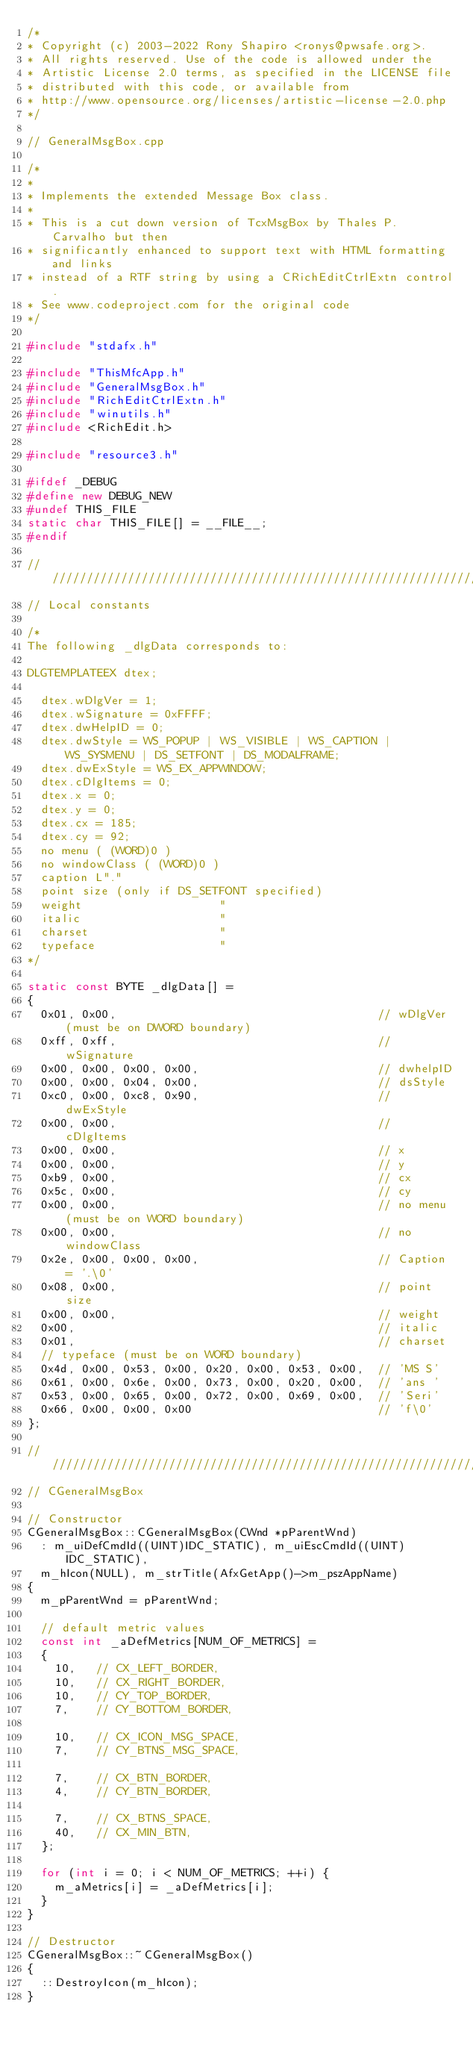<code> <loc_0><loc_0><loc_500><loc_500><_C++_>/*
* Copyright (c) 2003-2022 Rony Shapiro <ronys@pwsafe.org>.
* All rights reserved. Use of the code is allowed under the
* Artistic License 2.0 terms, as specified in the LICENSE file
* distributed with this code, or available from
* http://www.opensource.org/licenses/artistic-license-2.0.php
*/

// GeneralMsgBox.cpp

/*
*
* Implements the extended Message Box class.
*
* This is a cut down version of TcxMsgBox by Thales P. Carvalho but then
* significantly enhanced to support text with HTML formatting and links
* instead of a RTF string by using a CRichEditCtrlExtn control.
* See www.codeproject.com for the original code
*/

#include "stdafx.h"

#include "ThisMfcApp.h"
#include "GeneralMsgBox.h"
#include "RichEditCtrlExtn.h"
#include "winutils.h"
#include <RichEdit.h>

#include "resource3.h"

#ifdef _DEBUG
#define new DEBUG_NEW
#undef THIS_FILE
static char THIS_FILE[] = __FILE__;
#endif

/////////////////////////////////////////////////////////////////////////////
// Local constants

/*
The following _dlgData corresponds to:

DLGTEMPLATEEX dtex;

  dtex.wDlgVer = 1;
  dtex.wSignature = 0xFFFF;
  dtex.dwHelpID = 0;
  dtex.dwStyle = WS_POPUP | WS_VISIBLE | WS_CAPTION | WS_SYSMENU | DS_SETFONT | DS_MODALFRAME;
  dtex.dwExStyle = WS_EX_APPWINDOW;
  dtex.cDlgItems = 0;
  dtex.x = 0;
  dtex.y = 0;
  dtex.cx = 185;
  dtex.cy = 92;
  no menu ( (WORD)0 )
  no windowClass ( (WORD)0 )
  caption L"."
  point size (only if DS_SETFONT specified)
  weight                    "
  italic                    "
  charset                   "
  typeface                  "
*/

static const BYTE _dlgData[] =
{
  0x01, 0x00,                                      // wDlgVer (must be on DWORD boundary)
  0xff, 0xff,                                      // wSignature
  0x00, 0x00, 0x00, 0x00,                          // dwhelpID
  0x00, 0x00, 0x04, 0x00,                          // dsStyle
  0xc0, 0x00, 0xc8, 0x90,                          // dwExStyle
  0x00, 0x00,                                      // cDlgItems
  0x00, 0x00,                                      // x
  0x00, 0x00,                                      // y
  0xb9, 0x00,                                      // cx
  0x5c, 0x00,                                      // cy
  0x00, 0x00,                                      // no menu (must be on WORD boundary)
  0x00, 0x00,                                      // no windowClass
  0x2e, 0x00, 0x00, 0x00,                          // Caption = '.\0'
  0x08, 0x00,                                      // point size
  0x00, 0x00,                                      // weight
  0x00,                                            // italic
  0x01,                                            // charset
  // typeface (must be on WORD boundary)
  0x4d, 0x00, 0x53, 0x00, 0x20, 0x00, 0x53, 0x00,  // 'MS S'
  0x61, 0x00, 0x6e, 0x00, 0x73, 0x00, 0x20, 0x00,  // 'ans '
  0x53, 0x00, 0x65, 0x00, 0x72, 0x00, 0x69, 0x00,  // 'Seri'
  0x66, 0x00, 0x00, 0x00                           // 'f\0'
};

/////////////////////////////////////////////////////////////////////////////
// CGeneralMsgBox

// Constructor
CGeneralMsgBox::CGeneralMsgBox(CWnd *pParentWnd)
  : m_uiDefCmdId((UINT)IDC_STATIC), m_uiEscCmdId((UINT)IDC_STATIC),
  m_hIcon(NULL), m_strTitle(AfxGetApp()->m_pszAppName)
{
  m_pParentWnd = pParentWnd;

  // default metric values
  const int _aDefMetrics[NUM_OF_METRICS] =
  {
    10,   // CX_LEFT_BORDER,
    10,   // CX_RIGHT_BORDER,
    10,   // CY_TOP_BORDER,
    7,    // CY_BOTTOM_BORDER,

    10,   // CX_ICON_MSG_SPACE,
    7,    // CY_BTNS_MSG_SPACE,

    7,    // CX_BTN_BORDER,
    4,    // CY_BTN_BORDER,

    7,    // CX_BTNS_SPACE,
    40,   // CX_MIN_BTN,
  };

  for (int i = 0; i < NUM_OF_METRICS; ++i) {
    m_aMetrics[i] = _aDefMetrics[i];
  }
}

// Destructor
CGeneralMsgBox::~CGeneralMsgBox()
{
  ::DestroyIcon(m_hIcon);
}
</code> 